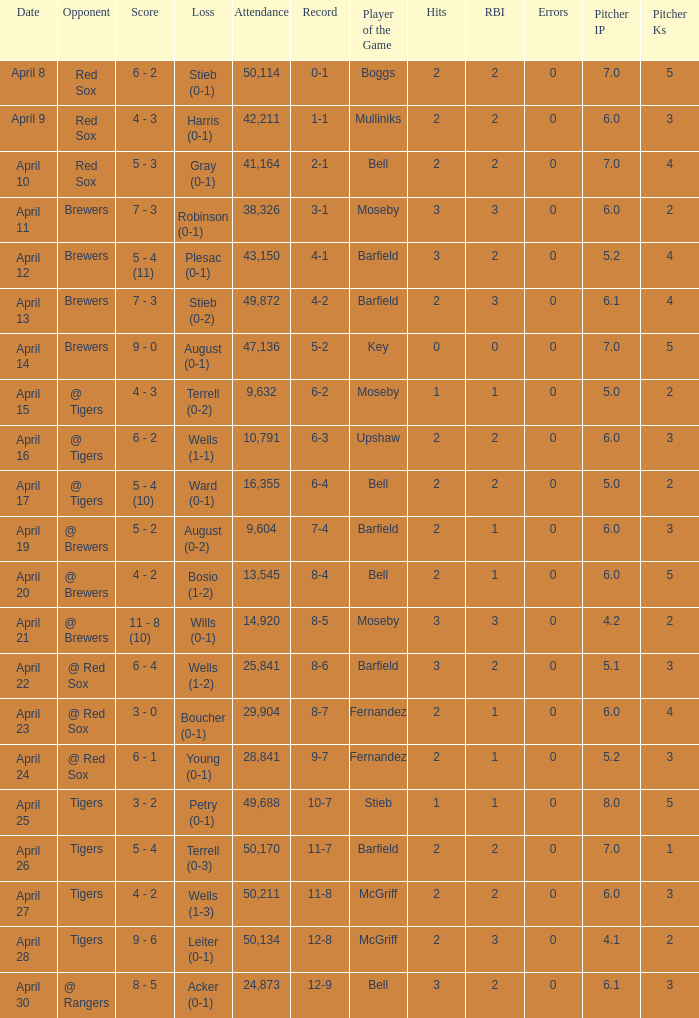Which opponent has an attendance greater than 29,904 and 11-8 as the record? Tigers. 